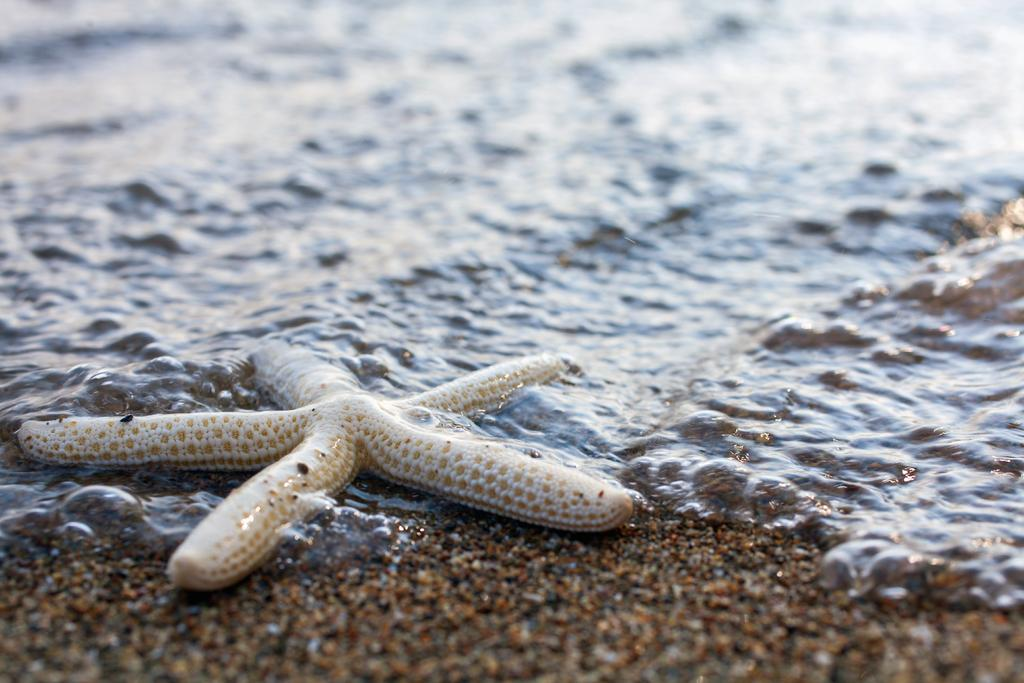What type of animal can be seen in the water in the image? There is a starfish in the water in the image. What type of terrain is visible in the image? There is sand visible in the image. Where is the nest located in the image? There is no nest present in the image. What type of vehicle can be seen driving on the sand in the image? There is no vehicle or driving activity present in the image. 